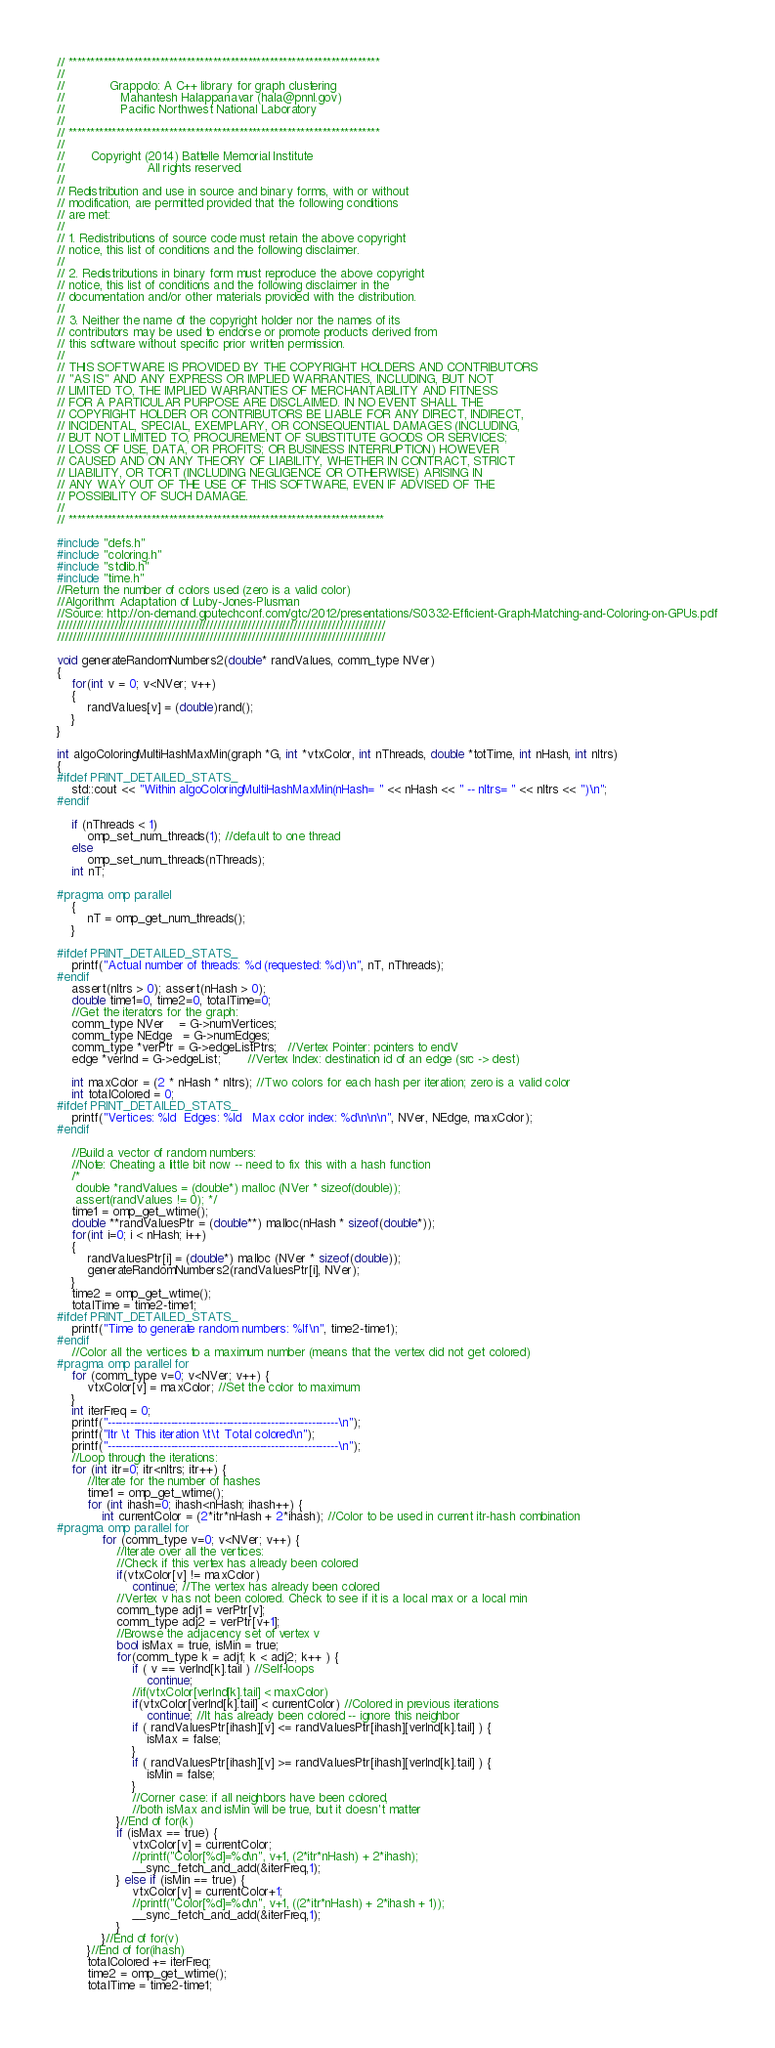<code> <loc_0><loc_0><loc_500><loc_500><_C++_>// ***********************************************************************
//
//            Grappolo: A C++ library for graph clustering
//               Mahantesh Halappanavar (hala@pnnl.gov)
//               Pacific Northwest National Laboratory
//
// ***********************************************************************
//
//       Copyright (2014) Battelle Memorial Institute
//                      All rights reserved.
//
// Redistribution and use in source and binary forms, with or without
// modification, are permitted provided that the following conditions
// are met:
//
// 1. Redistributions of source code must retain the above copyright
// notice, this list of conditions and the following disclaimer.
//
// 2. Redistributions in binary form must reproduce the above copyright
// notice, this list of conditions and the following disclaimer in the
// documentation and/or other materials provided with the distribution.
//
// 3. Neither the name of the copyright holder nor the names of its
// contributors may be used to endorse or promote products derived from
// this software without specific prior written permission.
//
// THIS SOFTWARE IS PROVIDED BY THE COPYRIGHT HOLDERS AND CONTRIBUTORS
// "AS IS" AND ANY EXPRESS OR IMPLIED WARRANTIES, INCLUDING, BUT NOT
// LIMITED TO, THE IMPLIED WARRANTIES OF MERCHANTABILITY AND FITNESS
// FOR A PARTICULAR PURPOSE ARE DISCLAIMED. IN NO EVENT SHALL THE
// COPYRIGHT HOLDER OR CONTRIBUTORS BE LIABLE FOR ANY DIRECT, INDIRECT,
// INCIDENTAL, SPECIAL, EXEMPLARY, OR CONSEQUENTIAL DAMAGES (INCLUDING,
// BUT NOT LIMITED TO, PROCUREMENT OF SUBSTITUTE GOODS OR SERVICES;
// LOSS OF USE, DATA, OR PROFITS; OR BUSINESS INTERRUPTION) HOWEVER
// CAUSED AND ON ANY THEORY OF LIABILITY, WHETHER IN CONTRACT, STRICT
// LIABILITY, OR TORT (INCLUDING NEGLIGENCE OR OTHERWISE) ARISING IN
// ANY WAY OUT OF THE USE OF THIS SOFTWARE, EVEN IF ADVISED OF THE
// POSSIBILITY OF SUCH DAMAGE.
//
// ************************************************************************

#include "defs.h"
#include "coloring.h"
#include "stdlib.h"
#include "time.h"
//Return the number of colors used (zero is a valid color)
//Algorithm: Adaptation of Luby-Jones-Plusman
//Source: http://on-demand.gputechconf.com/gtc/2012/presentations/S0332-Efficient-Graph-Matching-and-Coloring-on-GPUs.pdf
//////////////////////////////////////////////////////////////////////////////////////
//////////////////////////////////////////////////////////////////////////////////////

void generateRandomNumbers2(double* randValues, comm_type NVer)
{
    for(int v = 0; v<NVer; v++)
    {
        randValues[v] = (double)rand();
    }
}

int algoColoringMultiHashMaxMin(graph *G, int *vtxColor, int nThreads, double *totTime, int nHash, int nItrs)
{
#ifdef PRINT_DETAILED_STATS_
    std::cout << "Within algoColoringMultiHashMaxMin(nHash= " << nHash << " -- nItrs= " << nItrs << ")\n";
#endif
    
    if (nThreads < 1)
        omp_set_num_threads(1); //default to one thread
    else
        omp_set_num_threads(nThreads);
    int nT;
    
#pragma omp parallel
    {
        nT = omp_get_num_threads();
    }
    
#ifdef PRINT_DETAILED_STATS_
    printf("Actual number of threads: %d (requested: %d)\n", nT, nThreads);
#endif
    assert(nItrs > 0); assert(nHash > 0);
    double time1=0, time2=0, totalTime=0;
    //Get the iterators for the graph:
    comm_type NVer    = G->numVertices;
    comm_type NEdge   = G->numEdges;
    comm_type *verPtr = G->edgeListPtrs;   //Vertex Pointer: pointers to endV
    edge *verInd = G->edgeList;       //Vertex Index: destination id of an edge (src -> dest)
    
    int maxColor = (2 * nHash * nItrs); //Two colors for each hash per iteration; zero is a valid color
    int totalColored = 0;
#ifdef PRINT_DETAILED_STATS_
    printf("Vertices: %ld  Edges: %ld   Max color index: %d\n\n\n", NVer, NEdge, maxColor);
#endif
    
    //Build a vector of random numbers:
    //Note: Cheating a little bit now -- need to fix this with a hash function
    /*
     double *randValues = (double*) malloc (NVer * sizeof(double));
     assert(randValues != 0); */
    time1 = omp_get_wtime();
    double **randValuesPtr = (double**) malloc(nHash * sizeof(double*));
    for(int i=0; i < nHash; i++)
    {
        randValuesPtr[i] = (double*) malloc (NVer * sizeof(double));
        generateRandomNumbers2(randValuesPtr[i], NVer);
    }
    time2 = omp_get_wtime();
    totalTime = time2-time1;
#ifdef PRINT_DETAILED_STATS_
    printf("Time to generate random numbers: %lf\n", time2-time1);
#endif
    //Color all the vertices to a maximum number (means that the vertex did not get colored)
#pragma omp parallel for
    for (comm_type v=0; v<NVer; v++) {
        vtxColor[v] = maxColor; //Set the color to maximum
    }
    int iterFreq = 0;
    printf("--------------------------------------------------------------\n");
    printf("Itr \t This iteration \t\t Total colored\n");
    printf("--------------------------------------------------------------\n");
    //Loop through the iterations:
    for (int itr=0; itr<nItrs; itr++) {
        //Iterate for the number of hashes
        time1 = omp_get_wtime();
        for (int ihash=0; ihash<nHash; ihash++) {
            int currentColor = (2*itr*nHash + 2*ihash); //Color to be used in current itr-hash combination
#pragma omp parallel for
            for (comm_type v=0; v<NVer; v++) {
                //Iterate over all the vertices:
                //Check if this vertex has already been colored
                if(vtxColor[v] != maxColor)
                    continue; //The vertex has already been colored
                //Vertex v has not been colored. Check to see if it is a local max or a local min
                comm_type adj1 = verPtr[v];
                comm_type adj2 = verPtr[v+1];
                //Browse the adjacency set of vertex v
                bool isMax = true, isMin = true;
                for(comm_type k = adj1; k < adj2; k++ ) {
                    if ( v == verInd[k].tail ) //Self-loops
                        continue;
                    //if(vtxColor[verInd[k].tail] < maxColor)
                    if(vtxColor[verInd[k].tail] < currentColor) //Colored in previous iterations
                        continue; //It has already been colored -- ignore this neighbor
                    if ( randValuesPtr[ihash][v] <= randValuesPtr[ihash][verInd[k].tail] ) {
                        isMax = false;
                    }
                    if ( randValuesPtr[ihash][v] >= randValuesPtr[ihash][verInd[k].tail] ) {
                        isMin = false;
                    }
                    //Corner case: if all neighbors have been colored,
                    //both isMax and isMin will be true, but it doesn't matter
                }//End of for(k)
                if (isMax == true) {
                    vtxColor[v] = currentColor;
                    //printf("Color[%d]=%d\n", v+1, (2*itr*nHash) + 2*ihash);
                    __sync_fetch_and_add(&iterFreq,1);
                } else if (isMin == true) {
                    vtxColor[v] = currentColor+1;
                    //printf("Color[%d]=%d\n", v+1, ((2*itr*nHash) + 2*ihash + 1));
                    __sync_fetch_and_add(&iterFreq,1);
                }
            }//End of for(v)
        }//End of for(ihash)
        totalColored += iterFreq;
        time2 = omp_get_wtime();
        totalTime = time2-time1;</code> 